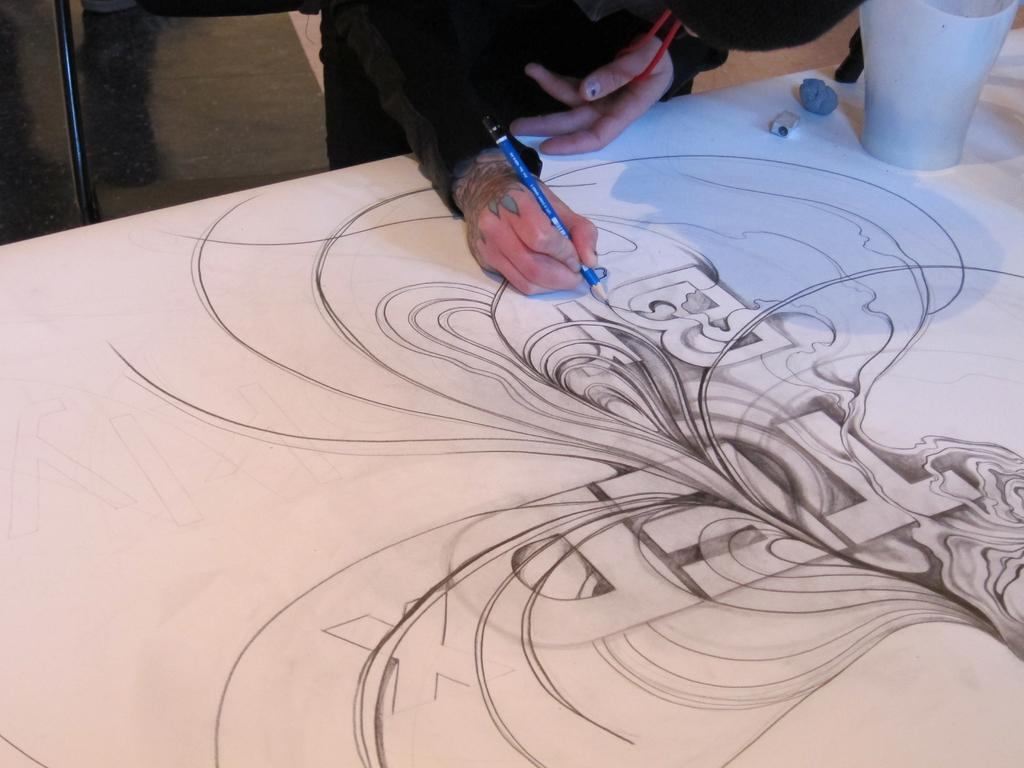What is the human in the image doing? The human is holding a pencil and drawing on a white surface. What is the human using to draw? The human is using a pencil to draw. What can be seen on the human's body in the image? There is a tattoo visible in the image. What is located at the top of the image? The top of the image includes a floor, rod, and a few objects. How many houses are visible in the image? There are no houses visible in the image. What type of patch is being sewn onto the human's clothing in the image? There is no patch being sewn onto the human's clothing in the image. 